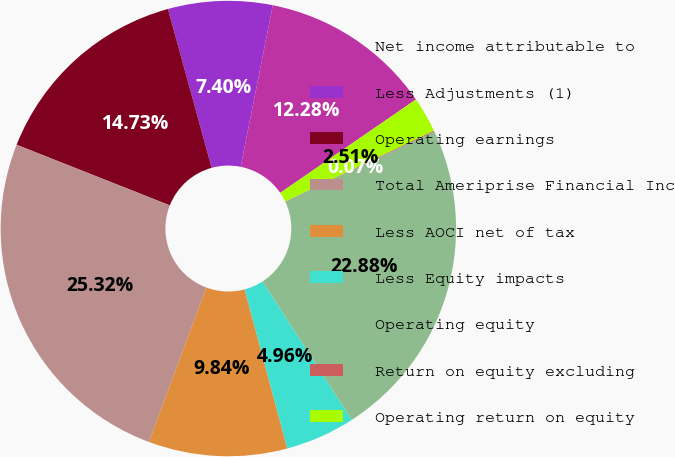Convert chart to OTSL. <chart><loc_0><loc_0><loc_500><loc_500><pie_chart><fcel>Net income attributable to<fcel>Less Adjustments (1)<fcel>Operating earnings<fcel>Total Ameriprise Financial Inc<fcel>Less AOCI net of tax<fcel>Less Equity impacts<fcel>Operating equity<fcel>Return on equity excluding<fcel>Operating return on equity<nl><fcel>12.28%<fcel>7.4%<fcel>14.73%<fcel>25.32%<fcel>9.84%<fcel>4.96%<fcel>22.88%<fcel>0.07%<fcel>2.51%<nl></chart> 